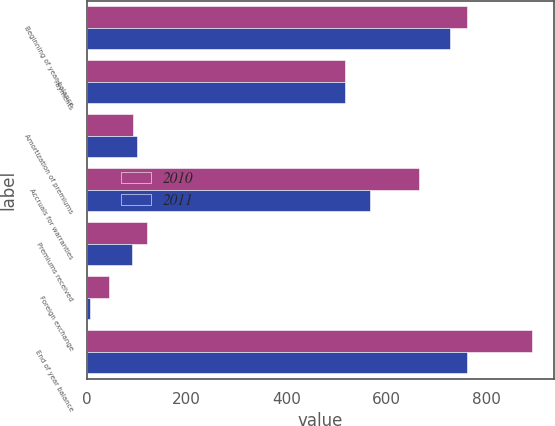Convert chart to OTSL. <chart><loc_0><loc_0><loc_500><loc_500><stacked_bar_chart><ecel><fcel>Beginning of year balance<fcel>Payments<fcel>Amortization of premiums<fcel>Accruals for warranties<fcel>Premiums received<fcel>Foreign exchange<fcel>End of year balance<nl><fcel>2010<fcel>762<fcel>517<fcel>93<fcel>665<fcel>120<fcel>45<fcel>892<nl><fcel>2011<fcel>727<fcel>517<fcel>100<fcel>568<fcel>90<fcel>6<fcel>762<nl></chart> 